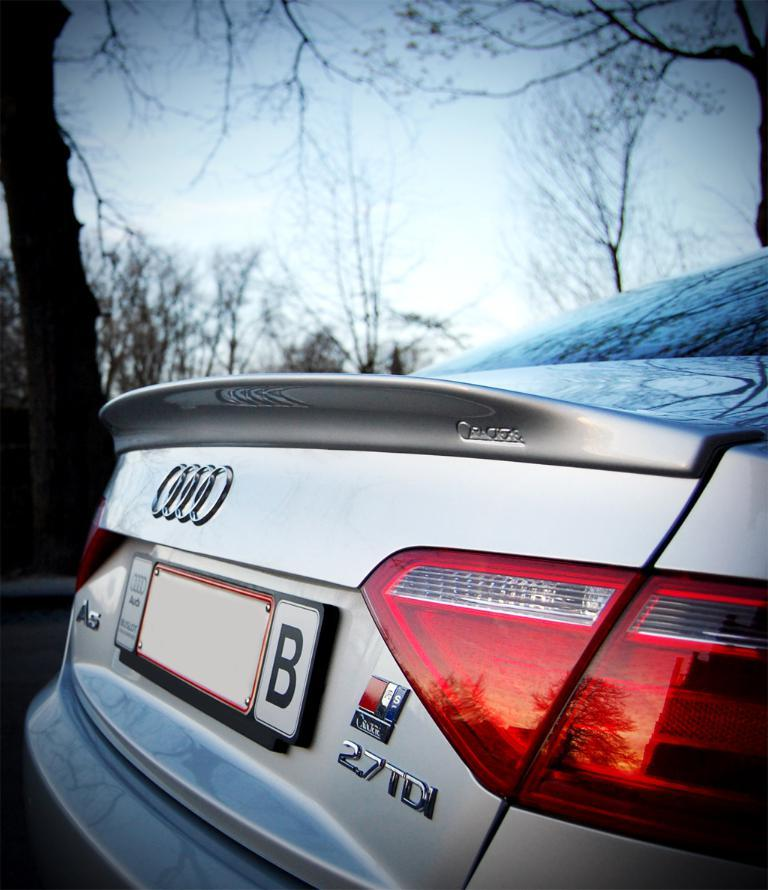<image>
Create a compact narrative representing the image presented. An Audi 27TDI is photographed from the trunk side. 